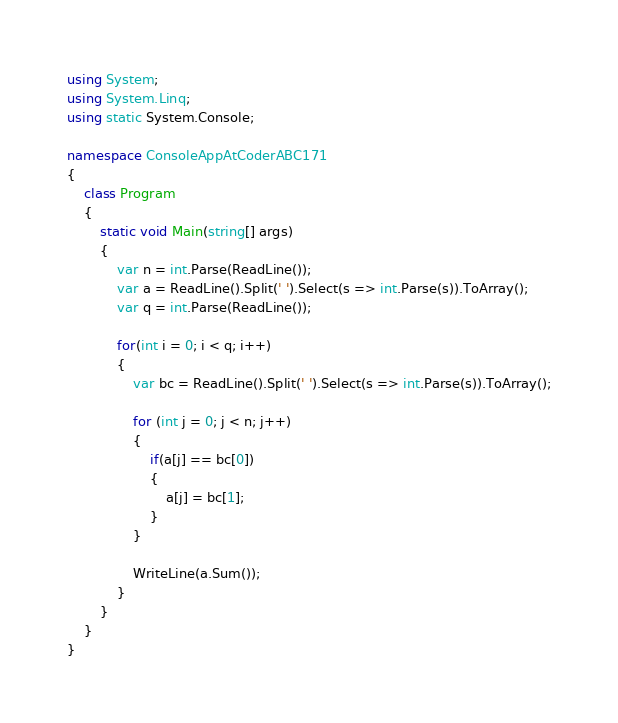Convert code to text. <code><loc_0><loc_0><loc_500><loc_500><_C#_>using System;
using System.Linq;
using static System.Console;

namespace ConsoleAppAtCoderABC171
{
    class Program
    {
        static void Main(string[] args)
        {
            var n = int.Parse(ReadLine());
            var a = ReadLine().Split(' ').Select(s => int.Parse(s)).ToArray();
            var q = int.Parse(ReadLine());

            for(int i = 0; i < q; i++)
            {
                var bc = ReadLine().Split(' ').Select(s => int.Parse(s)).ToArray();

                for (int j = 0; j < n; j++)
                {
                    if(a[j] == bc[0])
                    {
                        a[j] = bc[1];
                    }
                }

                WriteLine(a.Sum());
            }
        }
    }
}
</code> 